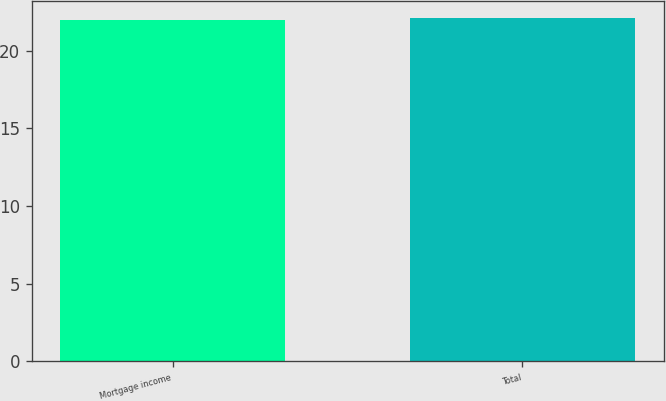Convert chart to OTSL. <chart><loc_0><loc_0><loc_500><loc_500><bar_chart><fcel>Mortgage income<fcel>Total<nl><fcel>22<fcel>22.1<nl></chart> 